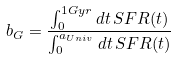<formula> <loc_0><loc_0><loc_500><loc_500>b _ { G } = \frac { \int _ { 0 } ^ { 1 G y r } d t \, S F R ( t ) } { \int _ { 0 } ^ { a _ { U n i v } } d t \, S F R ( t ) }</formula> 